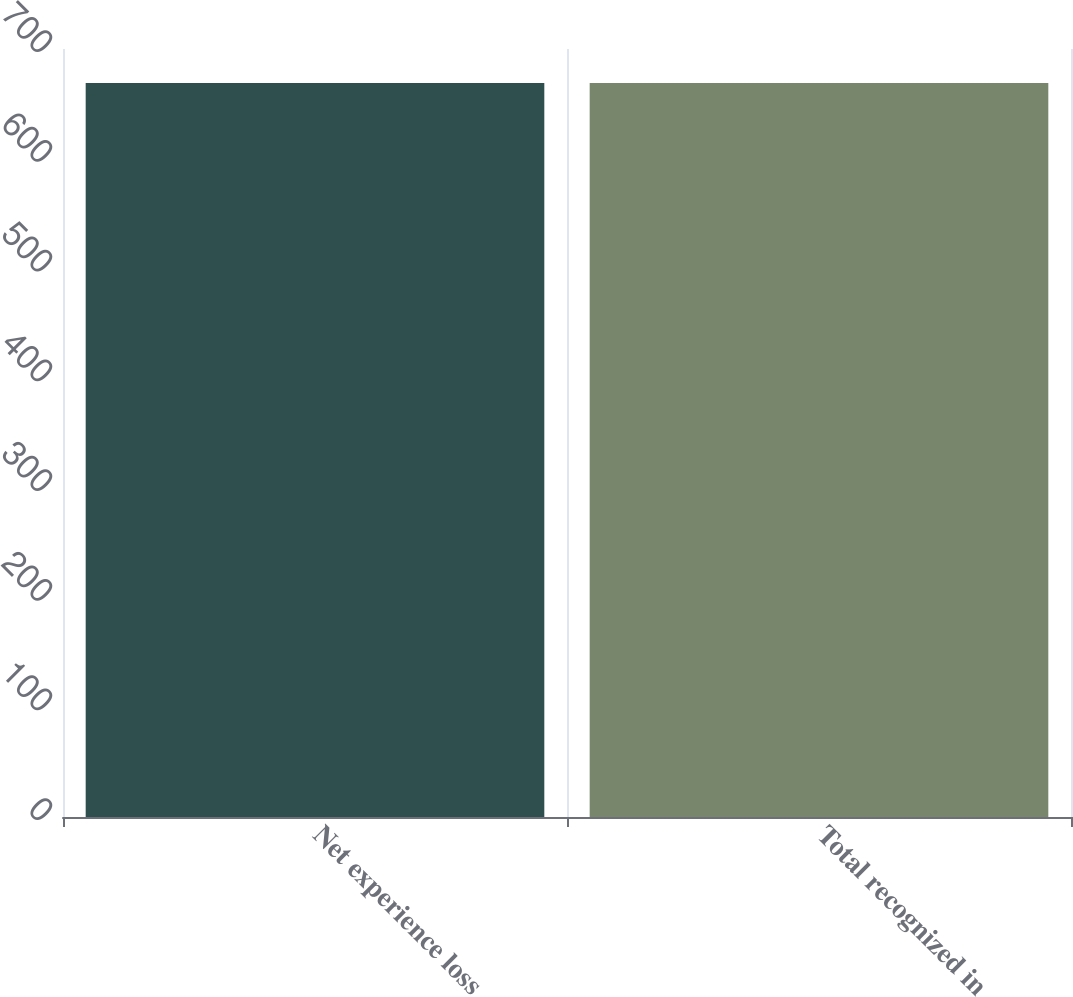<chart> <loc_0><loc_0><loc_500><loc_500><bar_chart><fcel>Net experience loss<fcel>Total recognized in<nl><fcel>669<fcel>669.1<nl></chart> 